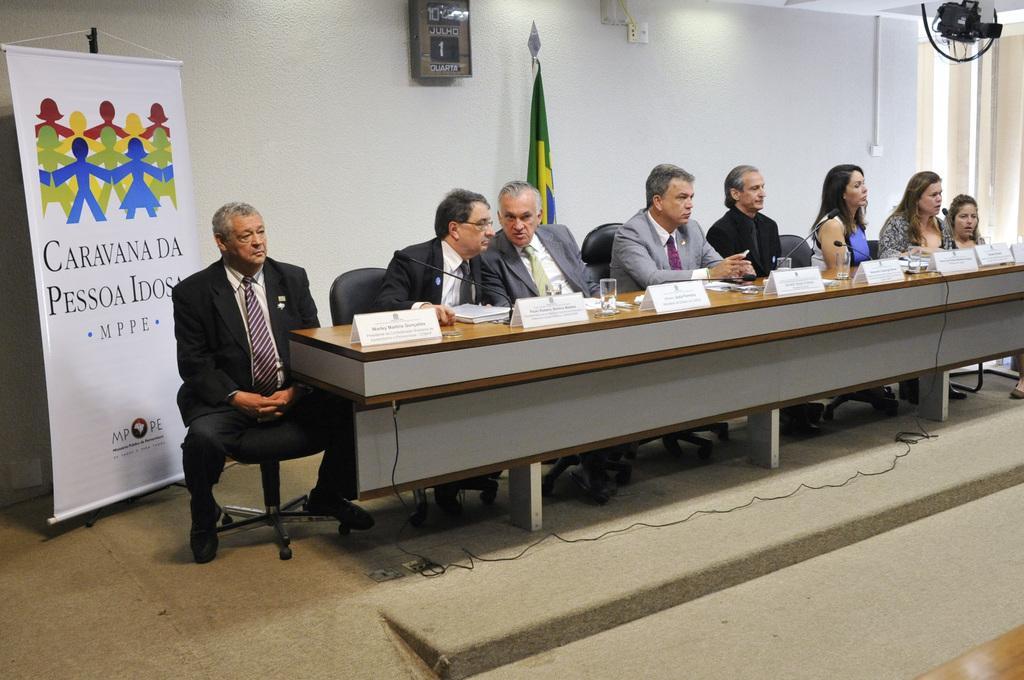How would you summarize this image in a sentence or two? This is a picture of a press conference. In this image there are eight people seated in the chairs, there are three women and five men. On the desk there are nameplates, files, papers , glasses, mike's. There is cable on the floor. In the background of the center there is a flag. On the left there is a banner. In the background on the wall there is a clock. On the top right there is a door and a camera. 